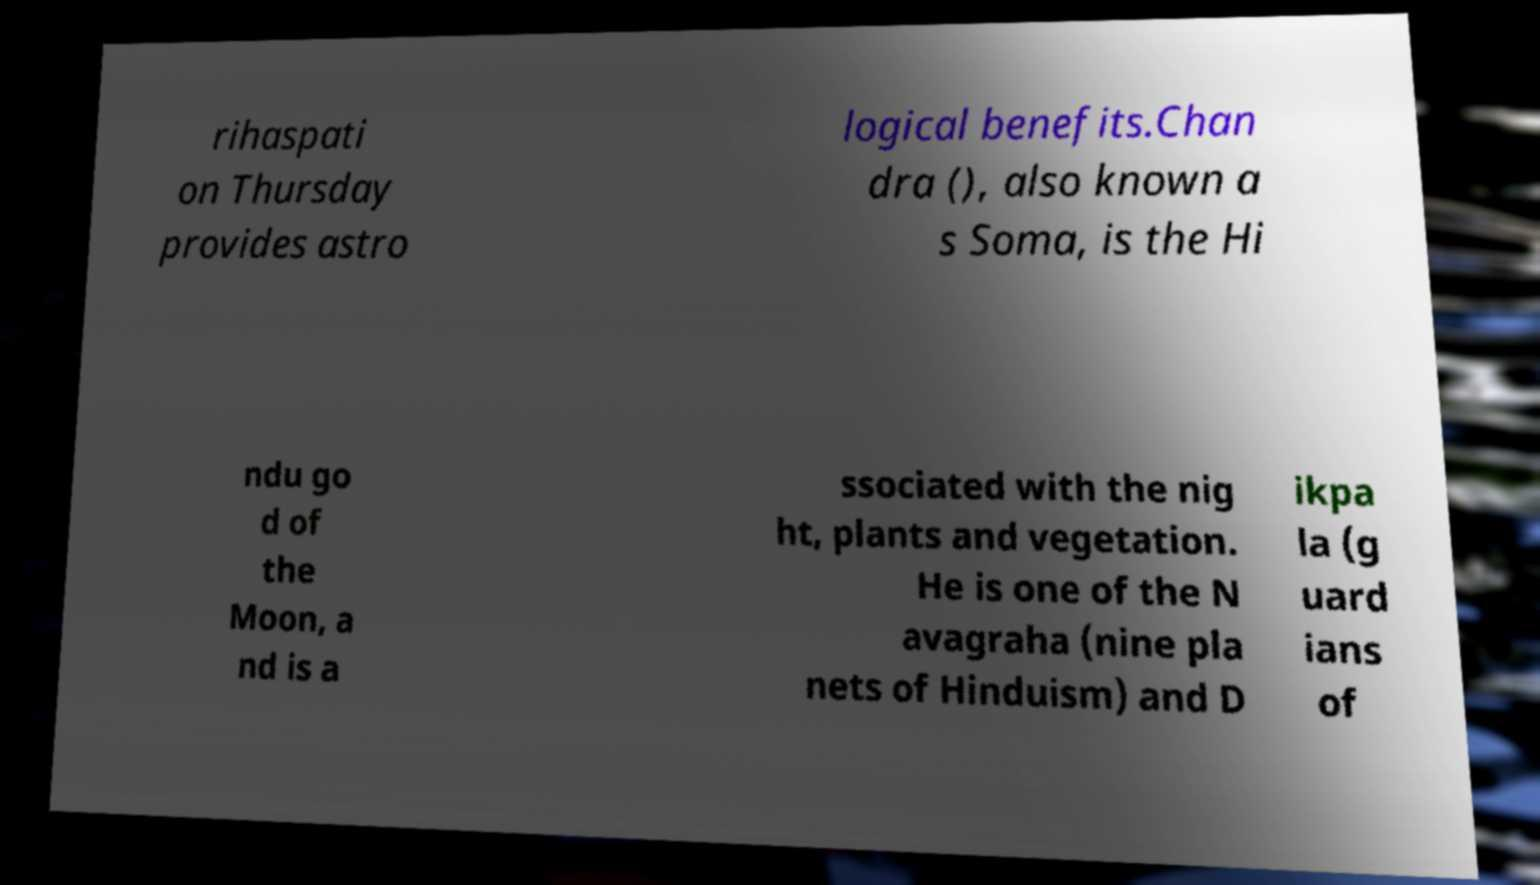What messages or text are displayed in this image? I need them in a readable, typed format. rihaspati on Thursday provides astro logical benefits.Chan dra (), also known a s Soma, is the Hi ndu go d of the Moon, a nd is a ssociated with the nig ht, plants and vegetation. He is one of the N avagraha (nine pla nets of Hinduism) and D ikpa la (g uard ians of 